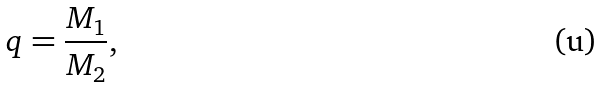<formula> <loc_0><loc_0><loc_500><loc_500>q = \frac { M _ { 1 } } { M _ { 2 } } ,</formula> 